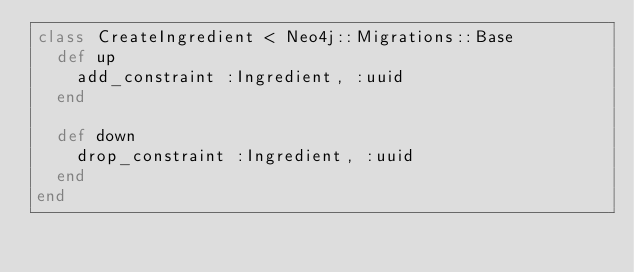<code> <loc_0><loc_0><loc_500><loc_500><_Ruby_>class CreateIngredient < Neo4j::Migrations::Base
  def up
    add_constraint :Ingredient, :uuid
  end

  def down
    drop_constraint :Ingredient, :uuid
  end
end
</code> 